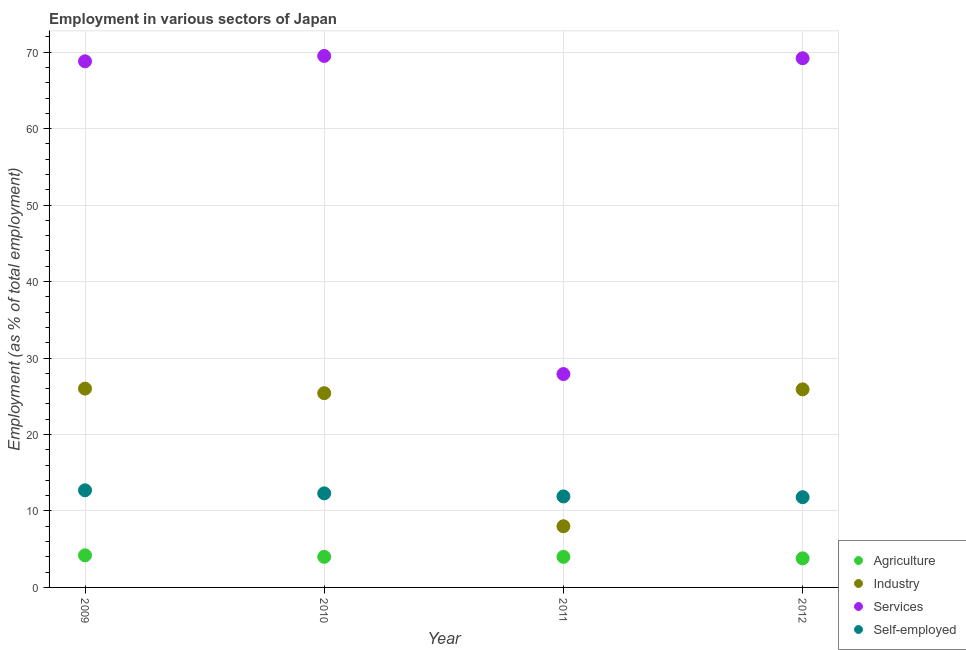What is the percentage of workers in agriculture in 2009?
Your answer should be compact. 4.2. Across all years, what is the maximum percentage of workers in agriculture?
Offer a very short reply. 4.2. Across all years, what is the minimum percentage of self employed workers?
Provide a short and direct response. 11.8. What is the total percentage of workers in services in the graph?
Your answer should be compact. 235.4. What is the difference between the percentage of workers in services in 2009 and that in 2012?
Give a very brief answer. -0.4. What is the difference between the percentage of workers in agriculture in 2010 and the percentage of self employed workers in 2012?
Your answer should be very brief. -7.8. What is the average percentage of workers in industry per year?
Provide a succinct answer. 21.32. In the year 2009, what is the difference between the percentage of self employed workers and percentage of workers in services?
Ensure brevity in your answer.  -56.1. In how many years, is the percentage of workers in industry greater than 26 %?
Offer a very short reply. 0. What is the ratio of the percentage of self employed workers in 2009 to that in 2012?
Offer a terse response. 1.08. What is the difference between the highest and the second highest percentage of self employed workers?
Offer a very short reply. 0.4. What is the difference between the highest and the lowest percentage of self employed workers?
Your response must be concise. 0.9. In how many years, is the percentage of workers in industry greater than the average percentage of workers in industry taken over all years?
Provide a succinct answer. 3. Is it the case that in every year, the sum of the percentage of workers in services and percentage of self employed workers is greater than the sum of percentage of workers in agriculture and percentage of workers in industry?
Provide a short and direct response. No. Does the percentage of self employed workers monotonically increase over the years?
Offer a terse response. No. Is the percentage of workers in agriculture strictly greater than the percentage of workers in industry over the years?
Offer a terse response. No. How many dotlines are there?
Provide a short and direct response. 4. How many years are there in the graph?
Provide a short and direct response. 4. How are the legend labels stacked?
Your answer should be very brief. Vertical. What is the title of the graph?
Give a very brief answer. Employment in various sectors of Japan. Does "Macroeconomic management" appear as one of the legend labels in the graph?
Keep it short and to the point. No. What is the label or title of the Y-axis?
Your response must be concise. Employment (as % of total employment). What is the Employment (as % of total employment) of Agriculture in 2009?
Ensure brevity in your answer.  4.2. What is the Employment (as % of total employment) in Services in 2009?
Offer a terse response. 68.8. What is the Employment (as % of total employment) of Self-employed in 2009?
Your response must be concise. 12.7. What is the Employment (as % of total employment) in Agriculture in 2010?
Your response must be concise. 4. What is the Employment (as % of total employment) in Industry in 2010?
Provide a succinct answer. 25.4. What is the Employment (as % of total employment) in Services in 2010?
Your response must be concise. 69.5. What is the Employment (as % of total employment) of Self-employed in 2010?
Provide a succinct answer. 12.3. What is the Employment (as % of total employment) in Agriculture in 2011?
Provide a succinct answer. 4. What is the Employment (as % of total employment) of Services in 2011?
Make the answer very short. 27.9. What is the Employment (as % of total employment) of Self-employed in 2011?
Keep it short and to the point. 11.9. What is the Employment (as % of total employment) of Agriculture in 2012?
Make the answer very short. 3.8. What is the Employment (as % of total employment) of Industry in 2012?
Provide a short and direct response. 25.9. What is the Employment (as % of total employment) of Services in 2012?
Offer a terse response. 69.2. What is the Employment (as % of total employment) in Self-employed in 2012?
Keep it short and to the point. 11.8. Across all years, what is the maximum Employment (as % of total employment) of Agriculture?
Provide a succinct answer. 4.2. Across all years, what is the maximum Employment (as % of total employment) in Industry?
Your answer should be very brief. 26. Across all years, what is the maximum Employment (as % of total employment) in Services?
Offer a very short reply. 69.5. Across all years, what is the maximum Employment (as % of total employment) of Self-employed?
Make the answer very short. 12.7. Across all years, what is the minimum Employment (as % of total employment) of Agriculture?
Make the answer very short. 3.8. Across all years, what is the minimum Employment (as % of total employment) of Services?
Offer a very short reply. 27.9. Across all years, what is the minimum Employment (as % of total employment) of Self-employed?
Give a very brief answer. 11.8. What is the total Employment (as % of total employment) in Agriculture in the graph?
Ensure brevity in your answer.  16. What is the total Employment (as % of total employment) of Industry in the graph?
Give a very brief answer. 85.3. What is the total Employment (as % of total employment) of Services in the graph?
Offer a very short reply. 235.4. What is the total Employment (as % of total employment) of Self-employed in the graph?
Provide a succinct answer. 48.7. What is the difference between the Employment (as % of total employment) in Self-employed in 2009 and that in 2010?
Provide a short and direct response. 0.4. What is the difference between the Employment (as % of total employment) of Agriculture in 2009 and that in 2011?
Your response must be concise. 0.2. What is the difference between the Employment (as % of total employment) of Services in 2009 and that in 2011?
Your answer should be compact. 40.9. What is the difference between the Employment (as % of total employment) in Self-employed in 2009 and that in 2011?
Keep it short and to the point. 0.8. What is the difference between the Employment (as % of total employment) in Agriculture in 2009 and that in 2012?
Your response must be concise. 0.4. What is the difference between the Employment (as % of total employment) in Industry in 2009 and that in 2012?
Keep it short and to the point. 0.1. What is the difference between the Employment (as % of total employment) in Self-employed in 2009 and that in 2012?
Offer a very short reply. 0.9. What is the difference between the Employment (as % of total employment) of Agriculture in 2010 and that in 2011?
Give a very brief answer. 0. What is the difference between the Employment (as % of total employment) in Industry in 2010 and that in 2011?
Your answer should be compact. 17.4. What is the difference between the Employment (as % of total employment) of Services in 2010 and that in 2011?
Your response must be concise. 41.6. What is the difference between the Employment (as % of total employment) in Agriculture in 2010 and that in 2012?
Provide a short and direct response. 0.2. What is the difference between the Employment (as % of total employment) of Services in 2010 and that in 2012?
Provide a short and direct response. 0.3. What is the difference between the Employment (as % of total employment) of Industry in 2011 and that in 2012?
Provide a short and direct response. -17.9. What is the difference between the Employment (as % of total employment) of Services in 2011 and that in 2012?
Make the answer very short. -41.3. What is the difference between the Employment (as % of total employment) of Self-employed in 2011 and that in 2012?
Your answer should be compact. 0.1. What is the difference between the Employment (as % of total employment) in Agriculture in 2009 and the Employment (as % of total employment) in Industry in 2010?
Offer a terse response. -21.2. What is the difference between the Employment (as % of total employment) of Agriculture in 2009 and the Employment (as % of total employment) of Services in 2010?
Give a very brief answer. -65.3. What is the difference between the Employment (as % of total employment) in Industry in 2009 and the Employment (as % of total employment) in Services in 2010?
Make the answer very short. -43.5. What is the difference between the Employment (as % of total employment) in Industry in 2009 and the Employment (as % of total employment) in Self-employed in 2010?
Ensure brevity in your answer.  13.7. What is the difference between the Employment (as % of total employment) of Services in 2009 and the Employment (as % of total employment) of Self-employed in 2010?
Give a very brief answer. 56.5. What is the difference between the Employment (as % of total employment) in Agriculture in 2009 and the Employment (as % of total employment) in Industry in 2011?
Ensure brevity in your answer.  -3.8. What is the difference between the Employment (as % of total employment) in Agriculture in 2009 and the Employment (as % of total employment) in Services in 2011?
Keep it short and to the point. -23.7. What is the difference between the Employment (as % of total employment) of Services in 2009 and the Employment (as % of total employment) of Self-employed in 2011?
Offer a terse response. 56.9. What is the difference between the Employment (as % of total employment) of Agriculture in 2009 and the Employment (as % of total employment) of Industry in 2012?
Your response must be concise. -21.7. What is the difference between the Employment (as % of total employment) of Agriculture in 2009 and the Employment (as % of total employment) of Services in 2012?
Your response must be concise. -65. What is the difference between the Employment (as % of total employment) of Agriculture in 2009 and the Employment (as % of total employment) of Self-employed in 2012?
Keep it short and to the point. -7.6. What is the difference between the Employment (as % of total employment) of Industry in 2009 and the Employment (as % of total employment) of Services in 2012?
Your answer should be very brief. -43.2. What is the difference between the Employment (as % of total employment) of Services in 2009 and the Employment (as % of total employment) of Self-employed in 2012?
Your answer should be compact. 57. What is the difference between the Employment (as % of total employment) in Agriculture in 2010 and the Employment (as % of total employment) in Industry in 2011?
Your response must be concise. -4. What is the difference between the Employment (as % of total employment) in Agriculture in 2010 and the Employment (as % of total employment) in Services in 2011?
Ensure brevity in your answer.  -23.9. What is the difference between the Employment (as % of total employment) of Agriculture in 2010 and the Employment (as % of total employment) of Self-employed in 2011?
Offer a terse response. -7.9. What is the difference between the Employment (as % of total employment) of Industry in 2010 and the Employment (as % of total employment) of Services in 2011?
Offer a very short reply. -2.5. What is the difference between the Employment (as % of total employment) in Services in 2010 and the Employment (as % of total employment) in Self-employed in 2011?
Keep it short and to the point. 57.6. What is the difference between the Employment (as % of total employment) of Agriculture in 2010 and the Employment (as % of total employment) of Industry in 2012?
Provide a succinct answer. -21.9. What is the difference between the Employment (as % of total employment) in Agriculture in 2010 and the Employment (as % of total employment) in Services in 2012?
Keep it short and to the point. -65.2. What is the difference between the Employment (as % of total employment) of Industry in 2010 and the Employment (as % of total employment) of Services in 2012?
Keep it short and to the point. -43.8. What is the difference between the Employment (as % of total employment) of Services in 2010 and the Employment (as % of total employment) of Self-employed in 2012?
Offer a very short reply. 57.7. What is the difference between the Employment (as % of total employment) of Agriculture in 2011 and the Employment (as % of total employment) of Industry in 2012?
Offer a very short reply. -21.9. What is the difference between the Employment (as % of total employment) in Agriculture in 2011 and the Employment (as % of total employment) in Services in 2012?
Provide a succinct answer. -65.2. What is the difference between the Employment (as % of total employment) in Agriculture in 2011 and the Employment (as % of total employment) in Self-employed in 2012?
Your answer should be very brief. -7.8. What is the difference between the Employment (as % of total employment) in Industry in 2011 and the Employment (as % of total employment) in Services in 2012?
Your answer should be compact. -61.2. What is the difference between the Employment (as % of total employment) of Services in 2011 and the Employment (as % of total employment) of Self-employed in 2012?
Your response must be concise. 16.1. What is the average Employment (as % of total employment) in Agriculture per year?
Provide a succinct answer. 4. What is the average Employment (as % of total employment) of Industry per year?
Your answer should be compact. 21.32. What is the average Employment (as % of total employment) in Services per year?
Keep it short and to the point. 58.85. What is the average Employment (as % of total employment) of Self-employed per year?
Provide a short and direct response. 12.18. In the year 2009, what is the difference between the Employment (as % of total employment) in Agriculture and Employment (as % of total employment) in Industry?
Ensure brevity in your answer.  -21.8. In the year 2009, what is the difference between the Employment (as % of total employment) in Agriculture and Employment (as % of total employment) in Services?
Ensure brevity in your answer.  -64.6. In the year 2009, what is the difference between the Employment (as % of total employment) of Industry and Employment (as % of total employment) of Services?
Give a very brief answer. -42.8. In the year 2009, what is the difference between the Employment (as % of total employment) in Services and Employment (as % of total employment) in Self-employed?
Give a very brief answer. 56.1. In the year 2010, what is the difference between the Employment (as % of total employment) of Agriculture and Employment (as % of total employment) of Industry?
Provide a succinct answer. -21.4. In the year 2010, what is the difference between the Employment (as % of total employment) of Agriculture and Employment (as % of total employment) of Services?
Give a very brief answer. -65.5. In the year 2010, what is the difference between the Employment (as % of total employment) in Industry and Employment (as % of total employment) in Services?
Your answer should be very brief. -44.1. In the year 2010, what is the difference between the Employment (as % of total employment) of Industry and Employment (as % of total employment) of Self-employed?
Your answer should be very brief. 13.1. In the year 2010, what is the difference between the Employment (as % of total employment) of Services and Employment (as % of total employment) of Self-employed?
Your answer should be compact. 57.2. In the year 2011, what is the difference between the Employment (as % of total employment) in Agriculture and Employment (as % of total employment) in Industry?
Make the answer very short. -4. In the year 2011, what is the difference between the Employment (as % of total employment) of Agriculture and Employment (as % of total employment) of Services?
Keep it short and to the point. -23.9. In the year 2011, what is the difference between the Employment (as % of total employment) in Industry and Employment (as % of total employment) in Services?
Keep it short and to the point. -19.9. In the year 2011, what is the difference between the Employment (as % of total employment) in Industry and Employment (as % of total employment) in Self-employed?
Your answer should be very brief. -3.9. In the year 2011, what is the difference between the Employment (as % of total employment) in Services and Employment (as % of total employment) in Self-employed?
Ensure brevity in your answer.  16. In the year 2012, what is the difference between the Employment (as % of total employment) in Agriculture and Employment (as % of total employment) in Industry?
Keep it short and to the point. -22.1. In the year 2012, what is the difference between the Employment (as % of total employment) of Agriculture and Employment (as % of total employment) of Services?
Your answer should be very brief. -65.4. In the year 2012, what is the difference between the Employment (as % of total employment) of Agriculture and Employment (as % of total employment) of Self-employed?
Offer a terse response. -8. In the year 2012, what is the difference between the Employment (as % of total employment) of Industry and Employment (as % of total employment) of Services?
Give a very brief answer. -43.3. In the year 2012, what is the difference between the Employment (as % of total employment) of Industry and Employment (as % of total employment) of Self-employed?
Your answer should be compact. 14.1. In the year 2012, what is the difference between the Employment (as % of total employment) of Services and Employment (as % of total employment) of Self-employed?
Offer a very short reply. 57.4. What is the ratio of the Employment (as % of total employment) in Agriculture in 2009 to that in 2010?
Your answer should be very brief. 1.05. What is the ratio of the Employment (as % of total employment) in Industry in 2009 to that in 2010?
Offer a terse response. 1.02. What is the ratio of the Employment (as % of total employment) of Self-employed in 2009 to that in 2010?
Ensure brevity in your answer.  1.03. What is the ratio of the Employment (as % of total employment) in Industry in 2009 to that in 2011?
Ensure brevity in your answer.  3.25. What is the ratio of the Employment (as % of total employment) of Services in 2009 to that in 2011?
Keep it short and to the point. 2.47. What is the ratio of the Employment (as % of total employment) of Self-employed in 2009 to that in 2011?
Make the answer very short. 1.07. What is the ratio of the Employment (as % of total employment) in Agriculture in 2009 to that in 2012?
Ensure brevity in your answer.  1.11. What is the ratio of the Employment (as % of total employment) of Self-employed in 2009 to that in 2012?
Ensure brevity in your answer.  1.08. What is the ratio of the Employment (as % of total employment) in Industry in 2010 to that in 2011?
Provide a succinct answer. 3.17. What is the ratio of the Employment (as % of total employment) in Services in 2010 to that in 2011?
Provide a succinct answer. 2.49. What is the ratio of the Employment (as % of total employment) of Self-employed in 2010 to that in 2011?
Offer a very short reply. 1.03. What is the ratio of the Employment (as % of total employment) in Agriculture in 2010 to that in 2012?
Provide a short and direct response. 1.05. What is the ratio of the Employment (as % of total employment) of Industry in 2010 to that in 2012?
Offer a very short reply. 0.98. What is the ratio of the Employment (as % of total employment) of Self-employed in 2010 to that in 2012?
Your answer should be compact. 1.04. What is the ratio of the Employment (as % of total employment) of Agriculture in 2011 to that in 2012?
Your answer should be very brief. 1.05. What is the ratio of the Employment (as % of total employment) in Industry in 2011 to that in 2012?
Make the answer very short. 0.31. What is the ratio of the Employment (as % of total employment) of Services in 2011 to that in 2012?
Your response must be concise. 0.4. What is the ratio of the Employment (as % of total employment) of Self-employed in 2011 to that in 2012?
Your answer should be very brief. 1.01. What is the difference between the highest and the second highest Employment (as % of total employment) of Industry?
Offer a very short reply. 0.1. What is the difference between the highest and the second highest Employment (as % of total employment) in Services?
Provide a succinct answer. 0.3. What is the difference between the highest and the second highest Employment (as % of total employment) in Self-employed?
Offer a very short reply. 0.4. What is the difference between the highest and the lowest Employment (as % of total employment) of Industry?
Give a very brief answer. 18. What is the difference between the highest and the lowest Employment (as % of total employment) in Services?
Your answer should be compact. 41.6. What is the difference between the highest and the lowest Employment (as % of total employment) in Self-employed?
Offer a very short reply. 0.9. 